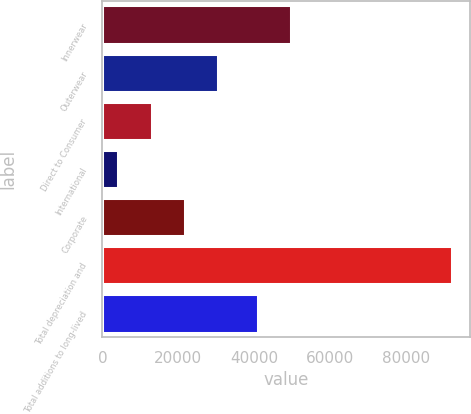Convert chart to OTSL. <chart><loc_0><loc_0><loc_500><loc_500><bar_chart><fcel>Innerwear<fcel>Outerwear<fcel>Direct to Consumer<fcel>International<fcel>Corporate<fcel>Total depreciation and<fcel>Total additions to long-lived<nl><fcel>49800.9<fcel>30583.7<fcel>12963.9<fcel>4154<fcel>21773.8<fcel>92253<fcel>40991<nl></chart> 